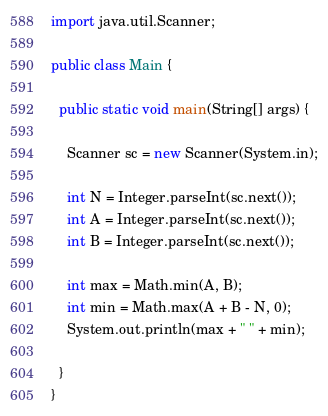Convert code to text. <code><loc_0><loc_0><loc_500><loc_500><_Java_>import java.util.Scanner;

public class Main {

  public static void main(String[] args) {

    Scanner sc = new Scanner(System.in);

    int N = Integer.parseInt(sc.next());
    int A = Integer.parseInt(sc.next());
    int B = Integer.parseInt(sc.next());

    int max = Math.min(A, B);
    int min = Math.max(A + B - N, 0);
    System.out.println(max + " " + min);

  }
}</code> 